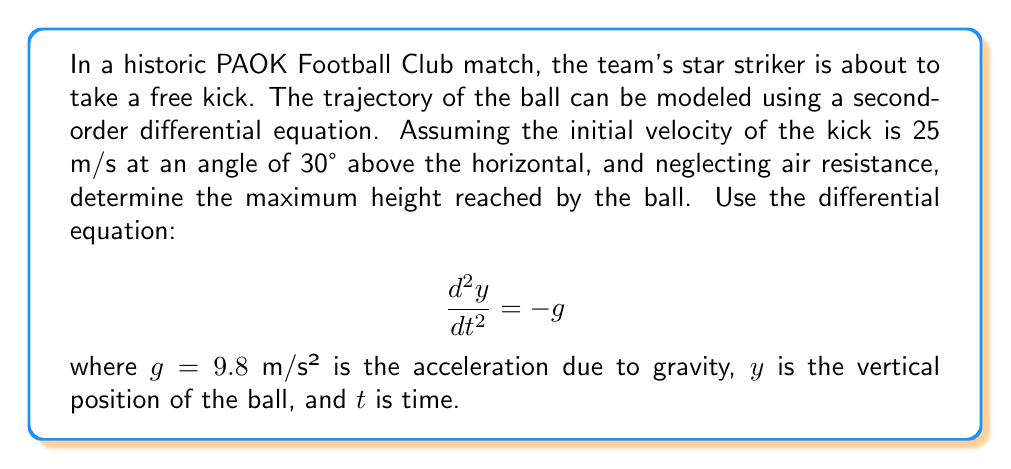Could you help me with this problem? To solve this problem, we'll follow these steps:

1) First, we need to set up our initial conditions. We know:
   - Initial velocity: $v_0 = 25$ m/s
   - Angle: $\theta = 30°$
   - Initial vertical velocity: $v_{0y} = v_0 \sin(\theta) = 25 \sin(30°) = 12.5$ m/s
   - Initial position: $y_0 = 0$ m (assuming the kick is taken at ground level)

2) The general solution to the differential equation $\frac{d^2y}{dt^2} = -g$ is:
   
   $$y(t) = -\frac{1}{2}gt^2 + v_{0y}t + y_0$$

3) Substituting our known values:

   $$y(t) = -4.9t^2 + 12.5t + 0$$

4) To find the maximum height, we need to find when the vertical velocity is zero:

   $$\frac{dy}{dt} = -9.8t + 12.5 = 0$$
   $$t = \frac{12.5}{9.8} \approx 1.276 \text{ seconds}$$

5) Now we can substitute this time back into our position equation:

   $$y_{max} = -4.9(1.276)^2 + 12.5(1.276) + 0$$
   $$y_{max} = -7.97 + 15.95 = 7.98 \text{ meters}$$

Therefore, the maximum height reached by the ball is approximately 7.98 meters.
Answer: The maximum height reached by the ball is approximately 7.98 meters. 